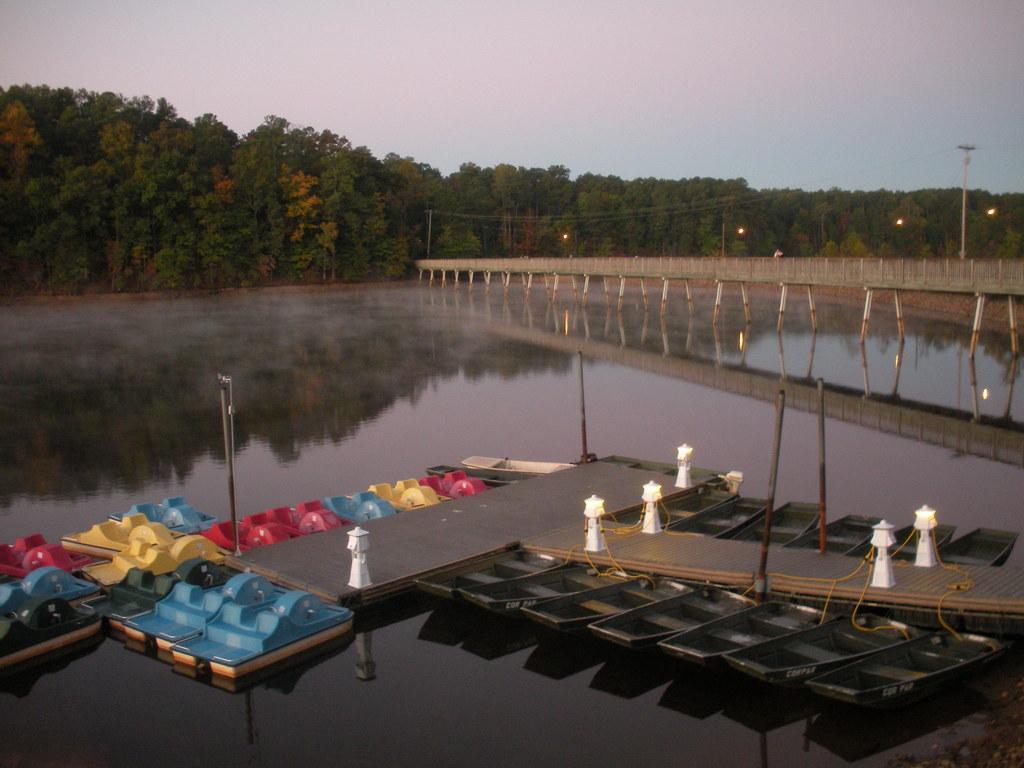Describe this image in one or two sentences. In this image I can see few boats. They are in black,red,green,blue and yellow color. I can see white poles,water,bridge,lights and trees. The sky is in white and blue color. 